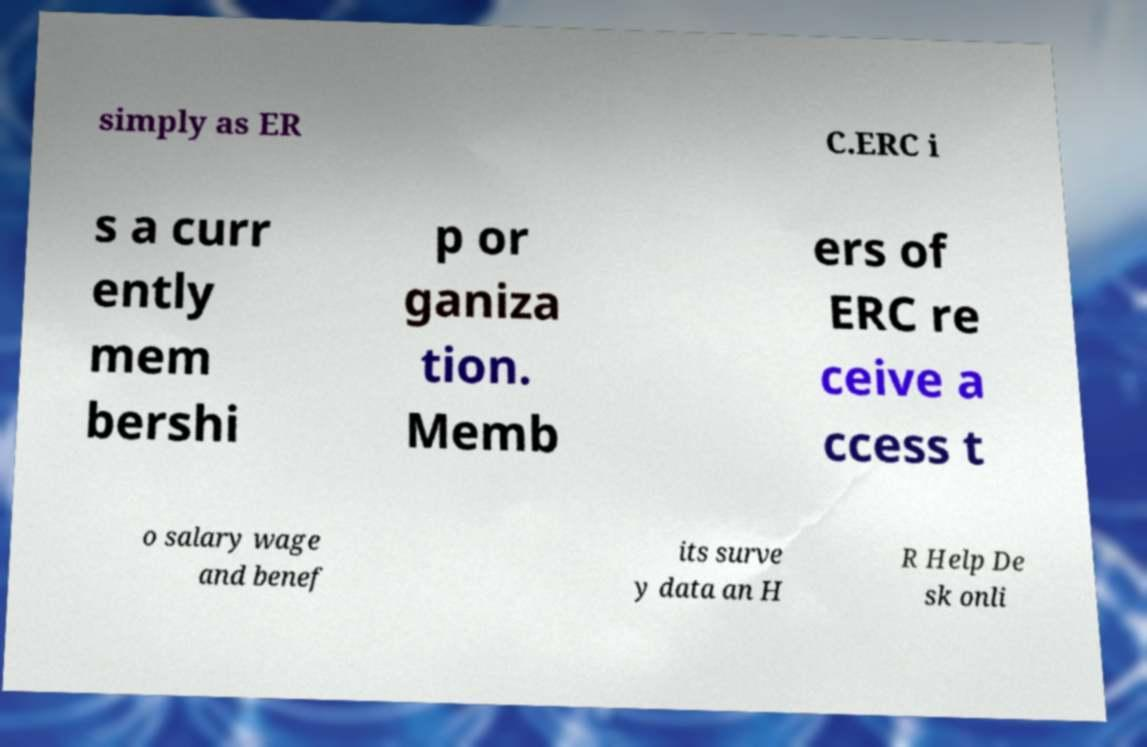There's text embedded in this image that I need extracted. Can you transcribe it verbatim? simply as ER C.ERC i s a curr ently mem bershi p or ganiza tion. Memb ers of ERC re ceive a ccess t o salary wage and benef its surve y data an H R Help De sk onli 